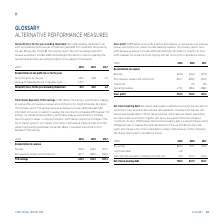According to Torm's financial document, How does TORM define gross profit? TORM defines Gross profit, a performance measure, as revenue less port expenses, bunkers and commissions, charter hire and operating expenses.. The document states: "Gross profit: TORM defines Gross profit, a performance measure, as revenue less port expenses, bunkers and commissions, charter hire and operating exp..." Also, Why does the company reports gross profit? it provides additional meaningful information to investors, as Gross profit measures the net earnings from shipping activities. The document states: "e Company reports Gross profit because we believe it provides additional meaningful information to investors, as Gross profit measures the net earning..." Also, What are the components under Reconciliation to revenue when calculating the gross profit? The document contains multiple relevant values: Revenue, Port expenses, bunkers and commissions, Charter hire, Operating expenses. From the document: "Port expenses, bunkers and commissions -267.7 -283.0 -259.9 Operating expenses -173.0 -180.4 -188.4 Reconciliation to revenue Charter hire - -2.5 -8.5..." Additionally, In which year was the amount of operating expenses the largest? According to the financial document, 2017. The relevant text states: "USDm 2019 2018 2017..." Also, can you calculate: What was the change in gross profit in 2019 from 2018? Based on the calculation: 251.9-169.5, the result is 82.4 (in millions). This is based on the information: "Gross profit 251.9 169.5 200.2 Gross profit 251.9 169.5 200.2..." The key data points involved are: 169.5, 251.9. Also, can you calculate: What was the percentage change in gross profit in 2019 from 2018? To answer this question, I need to perform calculations using the financial data. The calculation is: (251.9-169.5)/169.5, which equals 48.61 (percentage). This is based on the information: "Gross profit 251.9 169.5 200.2 Gross profit 251.9 169.5 200.2..." The key data points involved are: 169.5, 251.9. 